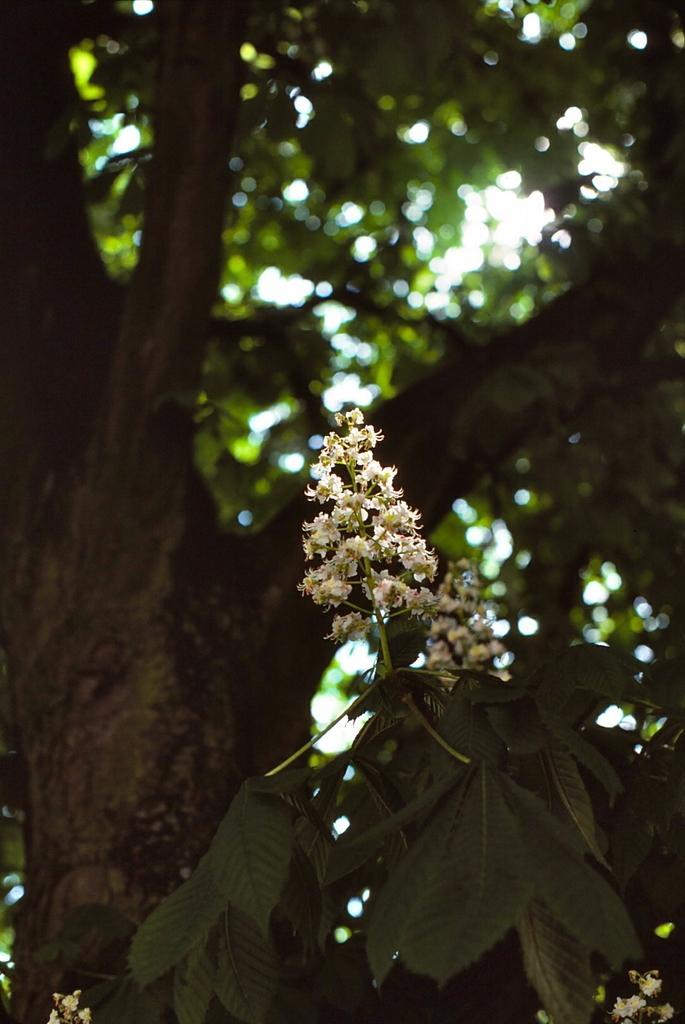Describe this image in one or two sentences. In this image I can see a tree and flowers. 